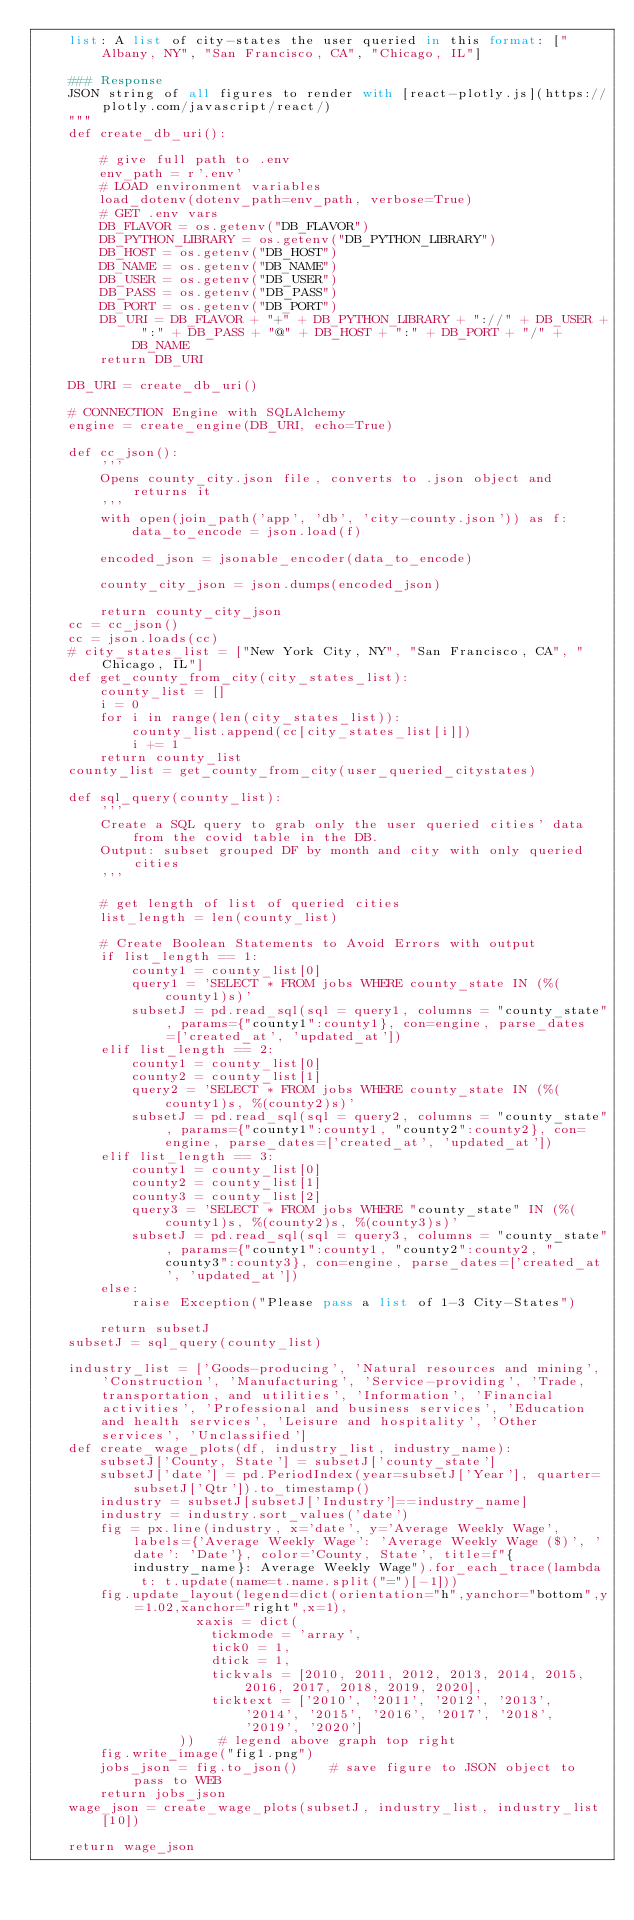Convert code to text. <code><loc_0><loc_0><loc_500><loc_500><_Python_>    list: A list of city-states the user queried in this format: ["Albany, NY", "San Francisco, CA", "Chicago, IL"]

    ### Response
    JSON string of all figures to render with [react-plotly.js](https://plotly.com/javascript/react/)
    """
    def create_db_uri():

        # give full path to .env
        env_path = r'.env'
        # LOAD environment variables
        load_dotenv(dotenv_path=env_path, verbose=True)
        # GET .env vars
        DB_FLAVOR = os.getenv("DB_FLAVOR")
        DB_PYTHON_LIBRARY = os.getenv("DB_PYTHON_LIBRARY")
        DB_HOST = os.getenv("DB_HOST")
        DB_NAME = os.getenv("DB_NAME")
        DB_USER = os.getenv("DB_USER")
        DB_PASS = os.getenv("DB_PASS")
        DB_PORT = os.getenv("DB_PORT")
        DB_URI = DB_FLAVOR + "+" + DB_PYTHON_LIBRARY + "://" + DB_USER + ":" + DB_PASS + "@" + DB_HOST + ":" + DB_PORT + "/" + DB_NAME
        return DB_URI
    
    DB_URI = create_db_uri()

    # CONNECTION Engine with SQLAlchemy
    engine = create_engine(DB_URI, echo=True)

    def cc_json():
        '''
        Opens county_city.json file, converts to .json object and returns it
        '''
        with open(join_path('app', 'db', 'city-county.json')) as f:
            data_to_encode = json.load(f)

        encoded_json = jsonable_encoder(data_to_encode)

        county_city_json = json.dumps(encoded_json)

        return county_city_json
    cc = cc_json()
    cc = json.loads(cc)
    # city_states_list = ["New York City, NY", "San Francisco, CA", "Chicago, IL"]
    def get_county_from_city(city_states_list):
        county_list = []
        i = 0
        for i in range(len(city_states_list)):
            county_list.append(cc[city_states_list[i]])
            i += 1
        return county_list
    county_list = get_county_from_city(user_queried_citystates)

    def sql_query(county_list):
        '''
        Create a SQL query to grab only the user queried cities' data from the covid table in the DB.
        Output: subset grouped DF by month and city with only queried cities
        '''
        
        # get length of list of queried cities
        list_length = len(county_list)

        # Create Boolean Statements to Avoid Errors with output
        if list_length == 1:
            county1 = county_list[0]
            query1 = 'SELECT * FROM jobs WHERE county_state IN (%(county1)s)'
            subsetJ = pd.read_sql(sql = query1, columns = "county_state", params={"county1":county1}, con=engine, parse_dates=['created_at', 'updated_at'])
        elif list_length == 2:
            county1 = county_list[0]
            county2 = county_list[1]
            query2 = 'SELECT * FROM jobs WHERE county_state IN (%(county1)s, %(county2)s)'
            subsetJ = pd.read_sql(sql = query2, columns = "county_state", params={"county1":county1, "county2":county2}, con=engine, parse_dates=['created_at', 'updated_at'])
        elif list_length == 3:
            county1 = county_list[0]
            county2 = county_list[1]
            county3 = county_list[2]
            query3 = 'SELECT * FROM jobs WHERE "county_state" IN (%(county1)s, %(county2)s, %(county3)s)'
            subsetJ = pd.read_sql(sql = query3, columns = "county_state", params={"county1":county1, "county2":county2, "county3":county3}, con=engine, parse_dates=['created_at', 'updated_at'])
        else:
            raise Exception("Please pass a list of 1-3 City-States")

        return subsetJ
    subsetJ = sql_query(county_list)
    
    industry_list = ['Goods-producing', 'Natural resources and mining', 'Construction', 'Manufacturing', 'Service-providing', 'Trade, transportation, and utilities', 'Information', 'Financial activities', 'Professional and business services', 'Education and health services', 'Leisure and hospitality', 'Other services', 'Unclassified']
    def create_wage_plots(df, industry_list, industry_name):
        subsetJ['County, State'] = subsetJ['county_state']
        subsetJ['date'] = pd.PeriodIndex(year=subsetJ['Year'], quarter=subsetJ['Qtr']).to_timestamp()
        industry = subsetJ[subsetJ['Industry']==industry_name]
        industry = industry.sort_values('date')
        fig = px.line(industry, x='date', y='Average Weekly Wage', labels={'Average Weekly Wage': 'Average Weekly Wage ($)', 'date': 'Date'}, color='County, State', title=f"{industry_name}: Average Weekly Wage").for_each_trace(lambda t: t.update(name=t.name.split("=")[-1]))
        fig.update_layout(legend=dict(orientation="h",yanchor="bottom",y=1.02,xanchor="right",x=1),
                    xaxis = dict(
                      tickmode = 'array',
                      tick0 = 1,
                      dtick = 1,
                      tickvals = [2010, 2011, 2012, 2013, 2014, 2015, 2016, 2017, 2018, 2019, 2020],
                      ticktext = ['2010', '2011', '2012', '2013', '2014', '2015', '2016', '2017', '2018', '2019', '2020']
                  ))   # legend above graph top right
        fig.write_image("fig1.png")
        jobs_json = fig.to_json()    # save figure to JSON object to pass to WEB
        return jobs_json
    wage_json = create_wage_plots(subsetJ, industry_list, industry_list[10])

    return wage_json
</code> 